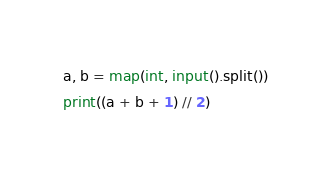<code> <loc_0><loc_0><loc_500><loc_500><_Python_>a, b = map(int, input().split())
print((a + b + 1) // 2)</code> 